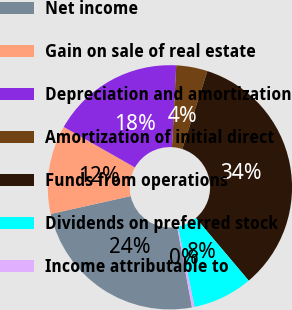Convert chart to OTSL. <chart><loc_0><loc_0><loc_500><loc_500><pie_chart><fcel>Net income<fcel>Gain on sale of real estate<fcel>Depreciation and amortization<fcel>Amortization of initial direct<fcel>Funds from operations<fcel>Dividends on preferred stock<fcel>Income attributable to<nl><fcel>24.39%<fcel>11.73%<fcel>17.6%<fcel>4.14%<fcel>33.87%<fcel>7.93%<fcel>0.34%<nl></chart> 